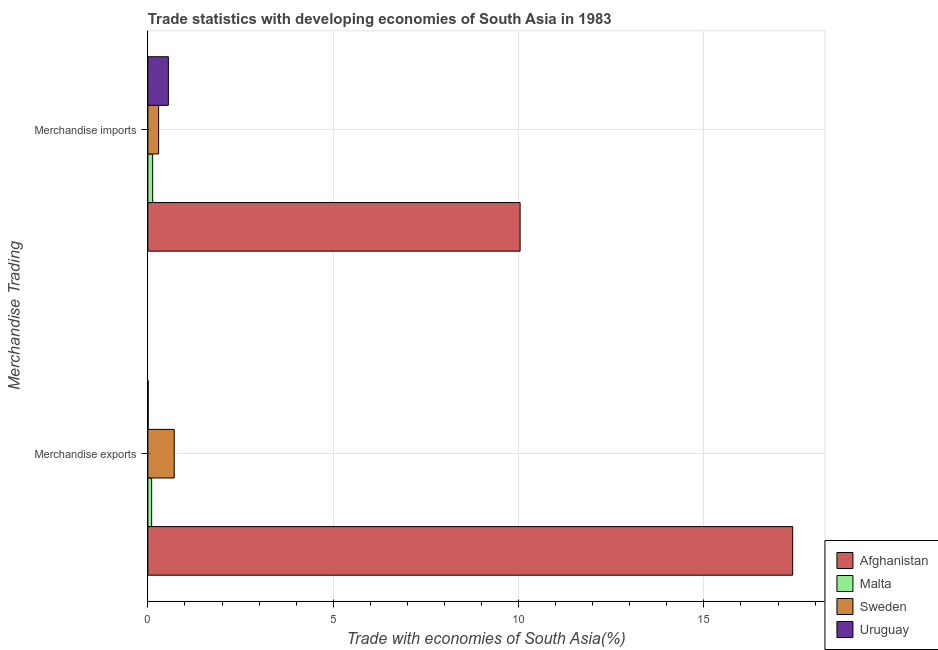How many different coloured bars are there?
Make the answer very short. 4. Are the number of bars on each tick of the Y-axis equal?
Make the answer very short. Yes. What is the label of the 1st group of bars from the top?
Ensure brevity in your answer.  Merchandise imports. What is the merchandise exports in Uruguay?
Make the answer very short. 0.01. Across all countries, what is the maximum merchandise exports?
Give a very brief answer. 17.4. Across all countries, what is the minimum merchandise imports?
Keep it short and to the point. 0.13. In which country was the merchandise imports maximum?
Provide a short and direct response. Afghanistan. In which country was the merchandise exports minimum?
Your response must be concise. Uruguay. What is the total merchandise exports in the graph?
Offer a terse response. 18.22. What is the difference between the merchandise exports in Uruguay and that in Malta?
Offer a terse response. -0.09. What is the difference between the merchandise imports in Sweden and the merchandise exports in Uruguay?
Provide a short and direct response. 0.28. What is the average merchandise exports per country?
Make the answer very short. 4.55. What is the difference between the merchandise imports and merchandise exports in Uruguay?
Your response must be concise. 0.54. What is the ratio of the merchandise imports in Afghanistan to that in Uruguay?
Your answer should be very brief. 18.17. What does the 4th bar from the top in Merchandise exports represents?
Your response must be concise. Afghanistan. What does the 1st bar from the bottom in Merchandise imports represents?
Offer a terse response. Afghanistan. How many bars are there?
Make the answer very short. 8. Does the graph contain any zero values?
Your answer should be very brief. No. Where does the legend appear in the graph?
Provide a succinct answer. Bottom right. How many legend labels are there?
Offer a very short reply. 4. How are the legend labels stacked?
Your response must be concise. Vertical. What is the title of the graph?
Give a very brief answer. Trade statistics with developing economies of South Asia in 1983. Does "Sierra Leone" appear as one of the legend labels in the graph?
Your answer should be compact. No. What is the label or title of the X-axis?
Offer a terse response. Trade with economies of South Asia(%). What is the label or title of the Y-axis?
Your answer should be very brief. Merchandise Trading. What is the Trade with economies of South Asia(%) in Afghanistan in Merchandise exports?
Provide a short and direct response. 17.4. What is the Trade with economies of South Asia(%) in Malta in Merchandise exports?
Your answer should be very brief. 0.1. What is the Trade with economies of South Asia(%) in Sweden in Merchandise exports?
Provide a short and direct response. 0.71. What is the Trade with economies of South Asia(%) of Uruguay in Merchandise exports?
Give a very brief answer. 0.01. What is the Trade with economies of South Asia(%) of Afghanistan in Merchandise imports?
Your answer should be compact. 10.04. What is the Trade with economies of South Asia(%) in Malta in Merchandise imports?
Your answer should be very brief. 0.13. What is the Trade with economies of South Asia(%) of Sweden in Merchandise imports?
Keep it short and to the point. 0.29. What is the Trade with economies of South Asia(%) of Uruguay in Merchandise imports?
Keep it short and to the point. 0.55. Across all Merchandise Trading, what is the maximum Trade with economies of South Asia(%) of Afghanistan?
Give a very brief answer. 17.4. Across all Merchandise Trading, what is the maximum Trade with economies of South Asia(%) in Malta?
Offer a terse response. 0.13. Across all Merchandise Trading, what is the maximum Trade with economies of South Asia(%) in Sweden?
Your answer should be very brief. 0.71. Across all Merchandise Trading, what is the maximum Trade with economies of South Asia(%) in Uruguay?
Make the answer very short. 0.55. Across all Merchandise Trading, what is the minimum Trade with economies of South Asia(%) in Afghanistan?
Your response must be concise. 10.04. Across all Merchandise Trading, what is the minimum Trade with economies of South Asia(%) in Malta?
Provide a short and direct response. 0.1. Across all Merchandise Trading, what is the minimum Trade with economies of South Asia(%) of Sweden?
Offer a very short reply. 0.29. Across all Merchandise Trading, what is the minimum Trade with economies of South Asia(%) in Uruguay?
Your response must be concise. 0.01. What is the total Trade with economies of South Asia(%) in Afghanistan in the graph?
Your answer should be compact. 27.44. What is the total Trade with economies of South Asia(%) in Malta in the graph?
Your answer should be compact. 0.23. What is the total Trade with economies of South Asia(%) in Uruguay in the graph?
Provide a short and direct response. 0.56. What is the difference between the Trade with economies of South Asia(%) in Afghanistan in Merchandise exports and that in Merchandise imports?
Your answer should be compact. 7.35. What is the difference between the Trade with economies of South Asia(%) in Malta in Merchandise exports and that in Merchandise imports?
Ensure brevity in your answer.  -0.03. What is the difference between the Trade with economies of South Asia(%) in Sweden in Merchandise exports and that in Merchandise imports?
Offer a very short reply. 0.42. What is the difference between the Trade with economies of South Asia(%) in Uruguay in Merchandise exports and that in Merchandise imports?
Ensure brevity in your answer.  -0.54. What is the difference between the Trade with economies of South Asia(%) of Afghanistan in Merchandise exports and the Trade with economies of South Asia(%) of Malta in Merchandise imports?
Your response must be concise. 17.27. What is the difference between the Trade with economies of South Asia(%) of Afghanistan in Merchandise exports and the Trade with economies of South Asia(%) of Sweden in Merchandise imports?
Give a very brief answer. 17.11. What is the difference between the Trade with economies of South Asia(%) of Afghanistan in Merchandise exports and the Trade with economies of South Asia(%) of Uruguay in Merchandise imports?
Give a very brief answer. 16.84. What is the difference between the Trade with economies of South Asia(%) in Malta in Merchandise exports and the Trade with economies of South Asia(%) in Sweden in Merchandise imports?
Your answer should be very brief. -0.19. What is the difference between the Trade with economies of South Asia(%) of Malta in Merchandise exports and the Trade with economies of South Asia(%) of Uruguay in Merchandise imports?
Give a very brief answer. -0.45. What is the difference between the Trade with economies of South Asia(%) in Sweden in Merchandise exports and the Trade with economies of South Asia(%) in Uruguay in Merchandise imports?
Offer a very short reply. 0.16. What is the average Trade with economies of South Asia(%) of Afghanistan per Merchandise Trading?
Offer a very short reply. 13.72. What is the average Trade with economies of South Asia(%) of Malta per Merchandise Trading?
Provide a succinct answer. 0.12. What is the average Trade with economies of South Asia(%) in Sweden per Merchandise Trading?
Provide a succinct answer. 0.5. What is the average Trade with economies of South Asia(%) of Uruguay per Merchandise Trading?
Offer a terse response. 0.28. What is the difference between the Trade with economies of South Asia(%) of Afghanistan and Trade with economies of South Asia(%) of Malta in Merchandise exports?
Provide a succinct answer. 17.29. What is the difference between the Trade with economies of South Asia(%) of Afghanistan and Trade with economies of South Asia(%) of Sweden in Merchandise exports?
Make the answer very short. 16.68. What is the difference between the Trade with economies of South Asia(%) in Afghanistan and Trade with economies of South Asia(%) in Uruguay in Merchandise exports?
Your answer should be compact. 17.39. What is the difference between the Trade with economies of South Asia(%) in Malta and Trade with economies of South Asia(%) in Sweden in Merchandise exports?
Your answer should be very brief. -0.61. What is the difference between the Trade with economies of South Asia(%) of Malta and Trade with economies of South Asia(%) of Uruguay in Merchandise exports?
Offer a very short reply. 0.09. What is the difference between the Trade with economies of South Asia(%) of Sweden and Trade with economies of South Asia(%) of Uruguay in Merchandise exports?
Make the answer very short. 0.7. What is the difference between the Trade with economies of South Asia(%) of Afghanistan and Trade with economies of South Asia(%) of Malta in Merchandise imports?
Keep it short and to the point. 9.91. What is the difference between the Trade with economies of South Asia(%) of Afghanistan and Trade with economies of South Asia(%) of Sweden in Merchandise imports?
Ensure brevity in your answer.  9.75. What is the difference between the Trade with economies of South Asia(%) in Afghanistan and Trade with economies of South Asia(%) in Uruguay in Merchandise imports?
Provide a short and direct response. 9.49. What is the difference between the Trade with economies of South Asia(%) of Malta and Trade with economies of South Asia(%) of Sweden in Merchandise imports?
Offer a very short reply. -0.16. What is the difference between the Trade with economies of South Asia(%) of Malta and Trade with economies of South Asia(%) of Uruguay in Merchandise imports?
Offer a terse response. -0.42. What is the difference between the Trade with economies of South Asia(%) of Sweden and Trade with economies of South Asia(%) of Uruguay in Merchandise imports?
Your answer should be compact. -0.26. What is the ratio of the Trade with economies of South Asia(%) of Afghanistan in Merchandise exports to that in Merchandise imports?
Give a very brief answer. 1.73. What is the ratio of the Trade with economies of South Asia(%) of Malta in Merchandise exports to that in Merchandise imports?
Make the answer very short. 0.79. What is the ratio of the Trade with economies of South Asia(%) in Sweden in Merchandise exports to that in Merchandise imports?
Keep it short and to the point. 2.45. What is the ratio of the Trade with economies of South Asia(%) of Uruguay in Merchandise exports to that in Merchandise imports?
Your answer should be compact. 0.01. What is the difference between the highest and the second highest Trade with economies of South Asia(%) in Afghanistan?
Ensure brevity in your answer.  7.35. What is the difference between the highest and the second highest Trade with economies of South Asia(%) of Malta?
Keep it short and to the point. 0.03. What is the difference between the highest and the second highest Trade with economies of South Asia(%) in Sweden?
Provide a succinct answer. 0.42. What is the difference between the highest and the second highest Trade with economies of South Asia(%) in Uruguay?
Your answer should be compact. 0.54. What is the difference between the highest and the lowest Trade with economies of South Asia(%) of Afghanistan?
Your answer should be compact. 7.35. What is the difference between the highest and the lowest Trade with economies of South Asia(%) of Malta?
Provide a short and direct response. 0.03. What is the difference between the highest and the lowest Trade with economies of South Asia(%) in Sweden?
Your answer should be compact. 0.42. What is the difference between the highest and the lowest Trade with economies of South Asia(%) of Uruguay?
Make the answer very short. 0.54. 